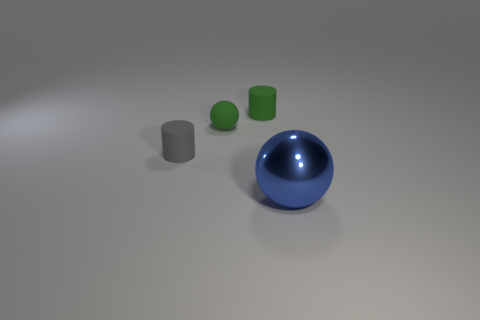There is a thing that is the same color as the matte sphere; what is its material?
Ensure brevity in your answer.  Rubber. What number of other things are there of the same color as the rubber sphere?
Your response must be concise. 1. Does the small gray thing have the same shape as the thing that is in front of the tiny gray matte cylinder?
Your response must be concise. No. The object that is to the left of the tiny green cylinder and behind the tiny gray rubber object is what color?
Offer a terse response. Green. Is there another tiny matte thing of the same shape as the gray thing?
Make the answer very short. Yes. Is the color of the large object the same as the rubber ball?
Provide a succinct answer. No. Are there any small balls in front of the ball that is left of the big sphere?
Your answer should be compact. No. How many objects are either spheres that are left of the big blue object or things behind the gray matte cylinder?
Give a very brief answer. 2. What number of objects are cylinders or objects to the left of the large blue shiny sphere?
Make the answer very short. 3. What size is the green thing to the left of the green rubber object on the right side of the tiny green rubber object that is on the left side of the green cylinder?
Make the answer very short. Small. 